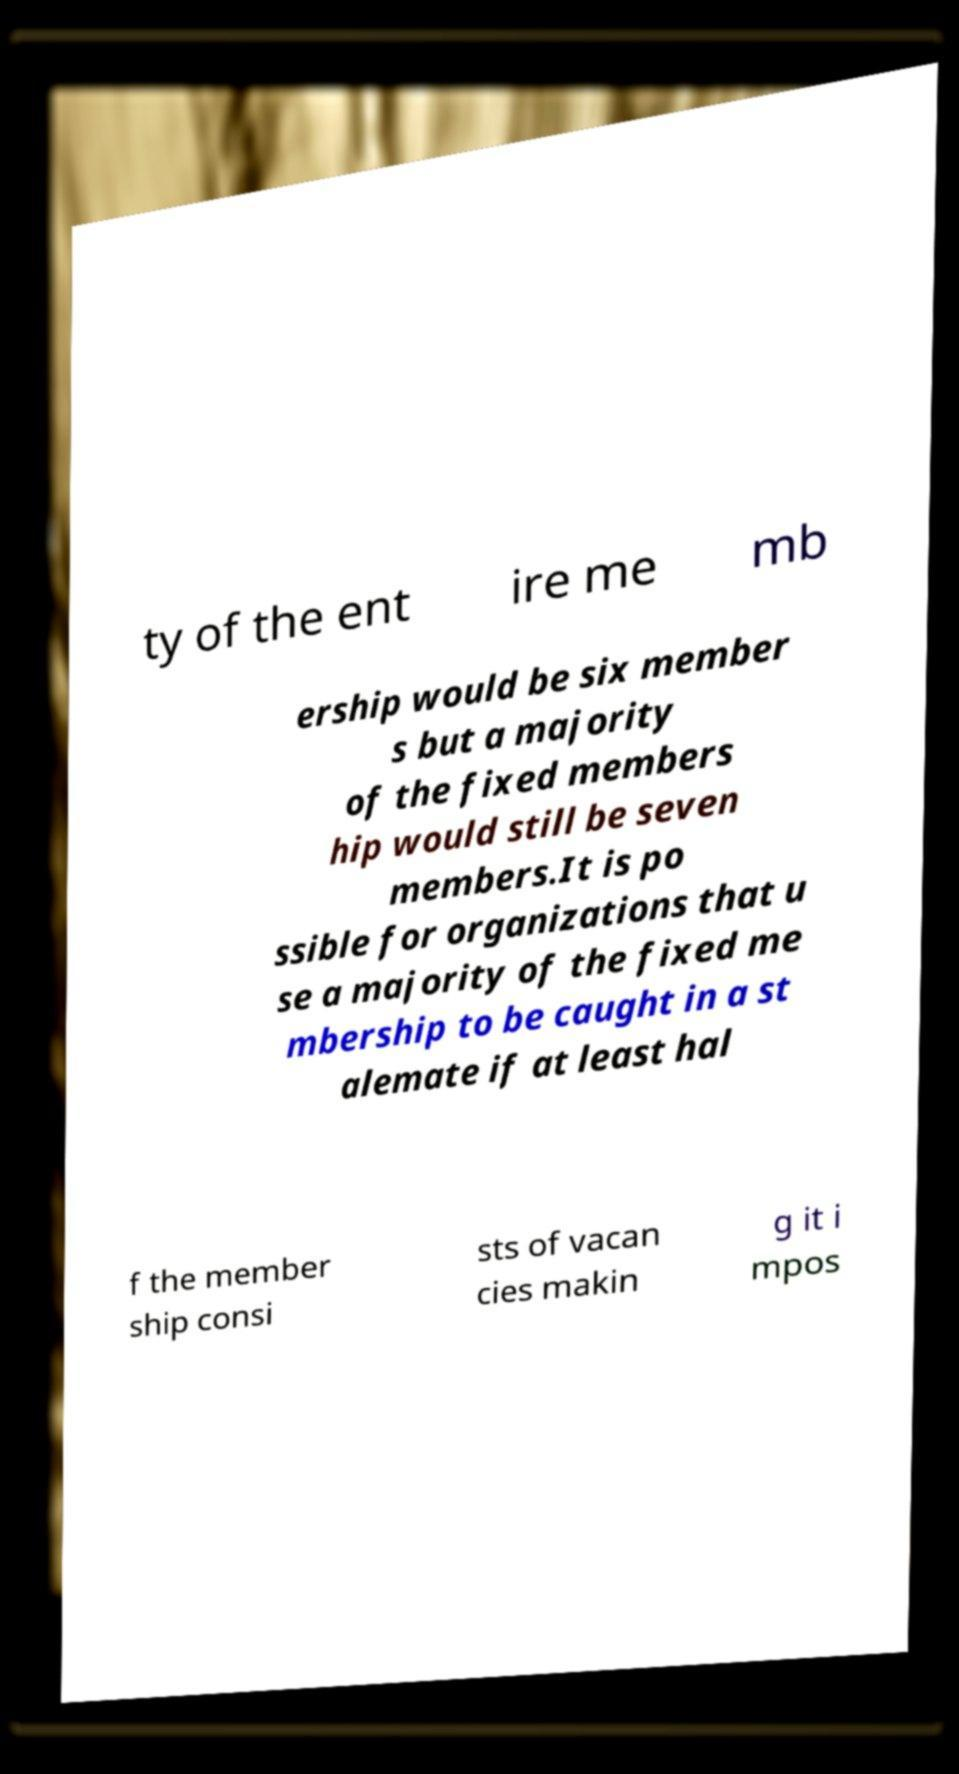Can you accurately transcribe the text from the provided image for me? ty of the ent ire me mb ership would be six member s but a majority of the fixed members hip would still be seven members.It is po ssible for organizations that u se a majority of the fixed me mbership to be caught in a st alemate if at least hal f the member ship consi sts of vacan cies makin g it i mpos 